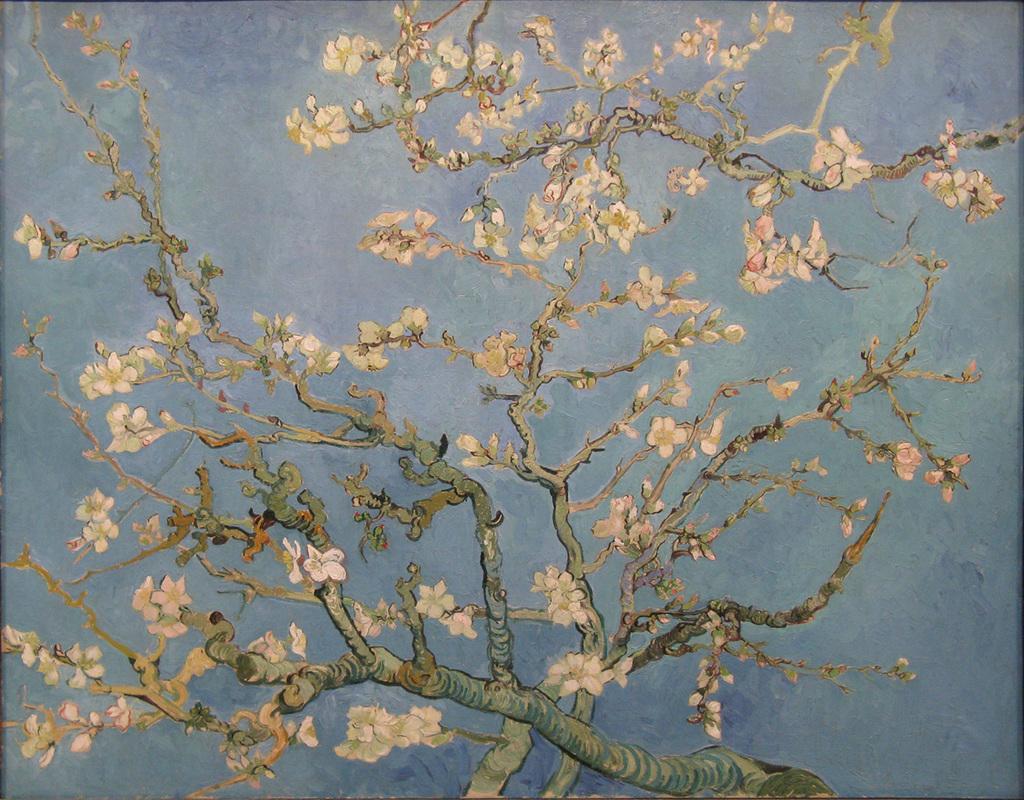Can you describe this image briefly? In this image, we can see the painting of a tree with some flowers on it. 